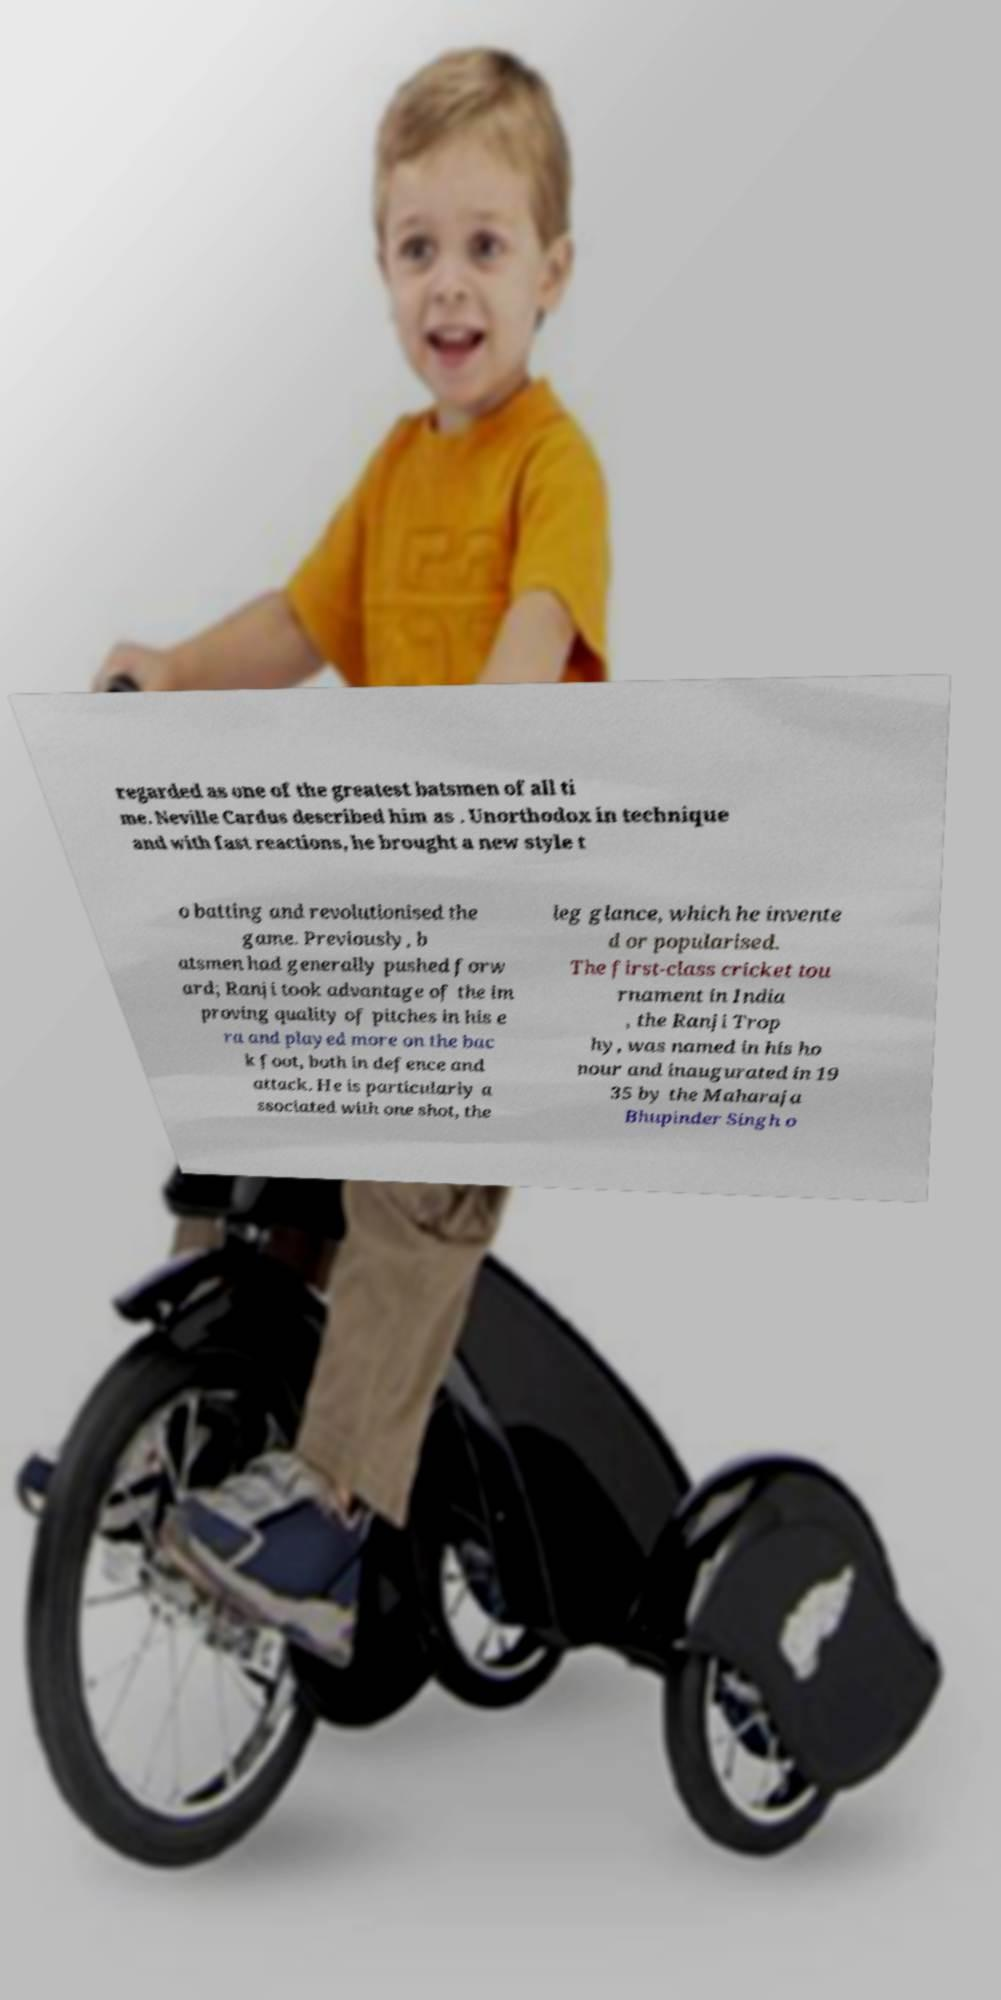What messages or text are displayed in this image? I need them in a readable, typed format. regarded as one of the greatest batsmen of all ti me. Neville Cardus described him as . Unorthodox in technique and with fast reactions, he brought a new style t o batting and revolutionised the game. Previously, b atsmen had generally pushed forw ard; Ranji took advantage of the im proving quality of pitches in his e ra and played more on the bac k foot, both in defence and attack. He is particularly a ssociated with one shot, the leg glance, which he invente d or popularised. The first-class cricket tou rnament in India , the Ranji Trop hy, was named in his ho nour and inaugurated in 19 35 by the Maharaja Bhupinder Singh o 